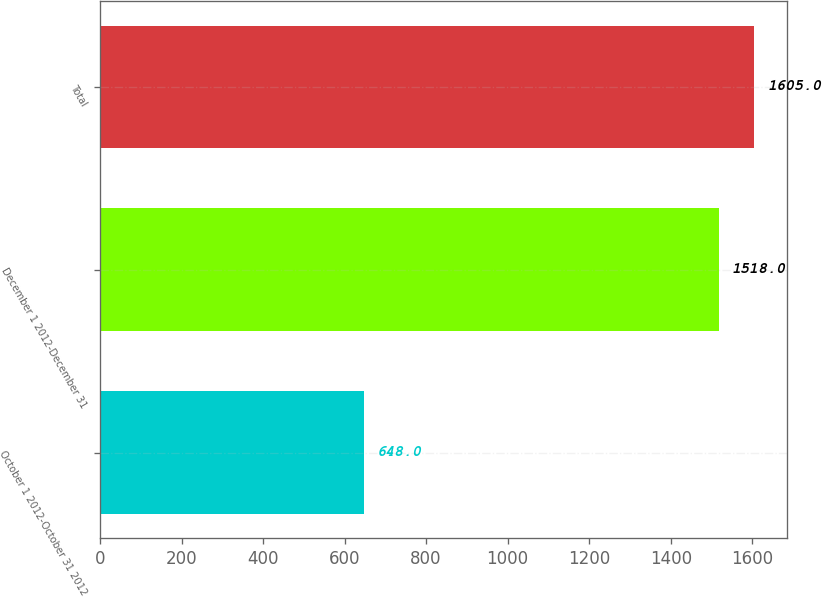Convert chart to OTSL. <chart><loc_0><loc_0><loc_500><loc_500><bar_chart><fcel>October 1 2012-October 31 2012<fcel>December 1 2012-December 31<fcel>Total<nl><fcel>648<fcel>1518<fcel>1605<nl></chart> 